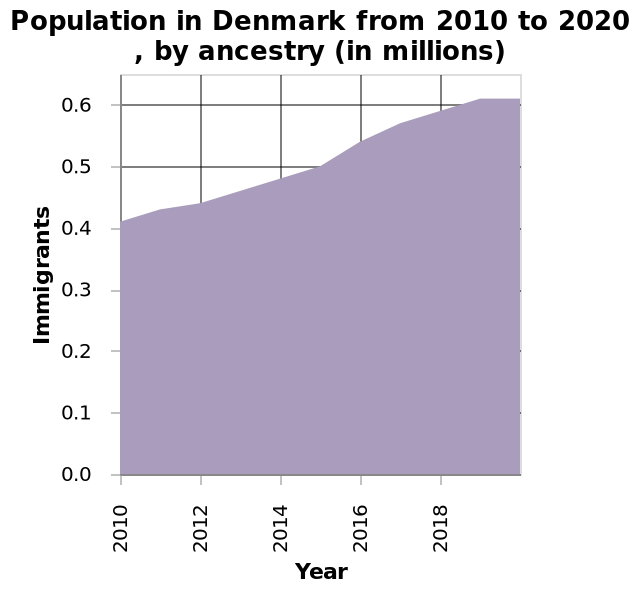<image>
What does the y-axis represent in this area chart? The y-axis represents the number of immigrants in Denmark, ranging from 0.0 to 0.6 on a scale. What was the initial population in 2010?  The initial population in 2010 was 0.4. What is the time period covered by this area chart? The area chart covers the years from 2010 to 2020 in Denmark. What is the title of the chart?  The title of the chart is "Population in Denmark from 2010 to 2020, by ancestry (in millions)". 